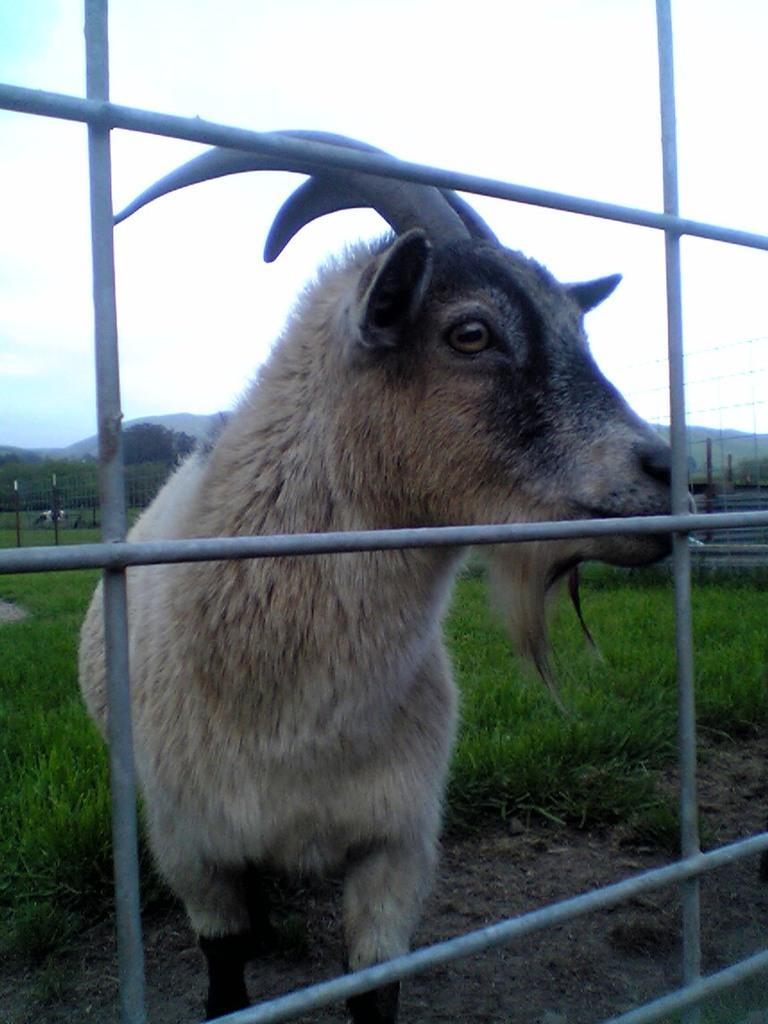What type of animal is present in the image? There is a goat in the image. What can be seen in the background of the image? There is an iron grill in the image. What type of boat is visible in the image? There is no boat present in the image; it features a goat and an iron grill. What type of apparel is the goat wearing in the image? The goat is not wearing any apparel in the image. 